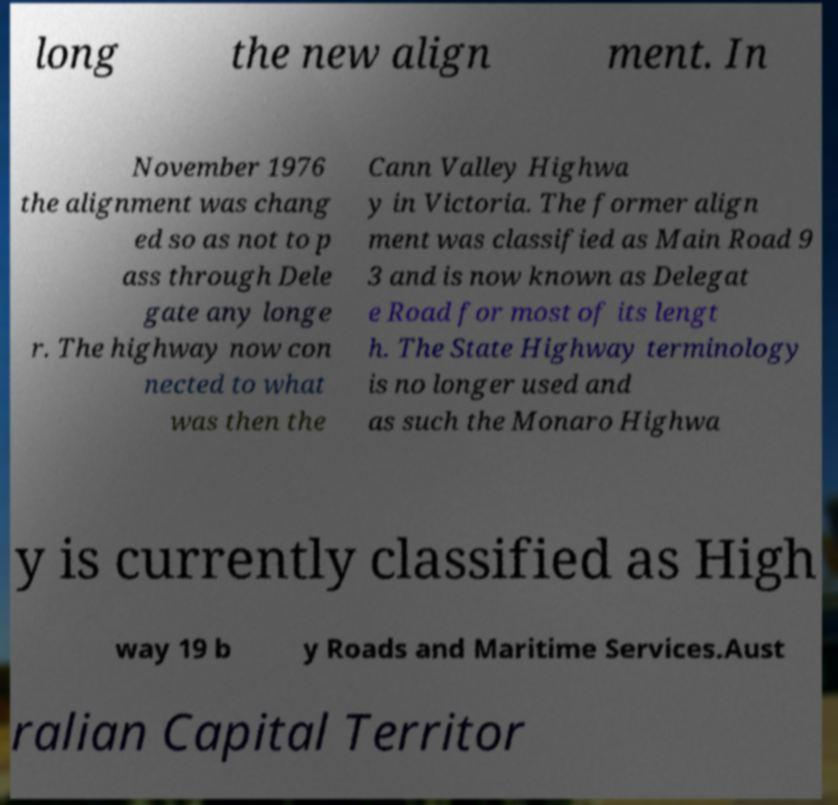What messages or text are displayed in this image? I need them in a readable, typed format. long the new align ment. In November 1976 the alignment was chang ed so as not to p ass through Dele gate any longe r. The highway now con nected to what was then the Cann Valley Highwa y in Victoria. The former align ment was classified as Main Road 9 3 and is now known as Delegat e Road for most of its lengt h. The State Highway terminology is no longer used and as such the Monaro Highwa y is currently classified as High way 19 b y Roads and Maritime Services.Aust ralian Capital Territor 